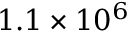Convert formula to latex. <formula><loc_0><loc_0><loc_500><loc_500>1 . 1 \times 1 0 ^ { 6 }</formula> 